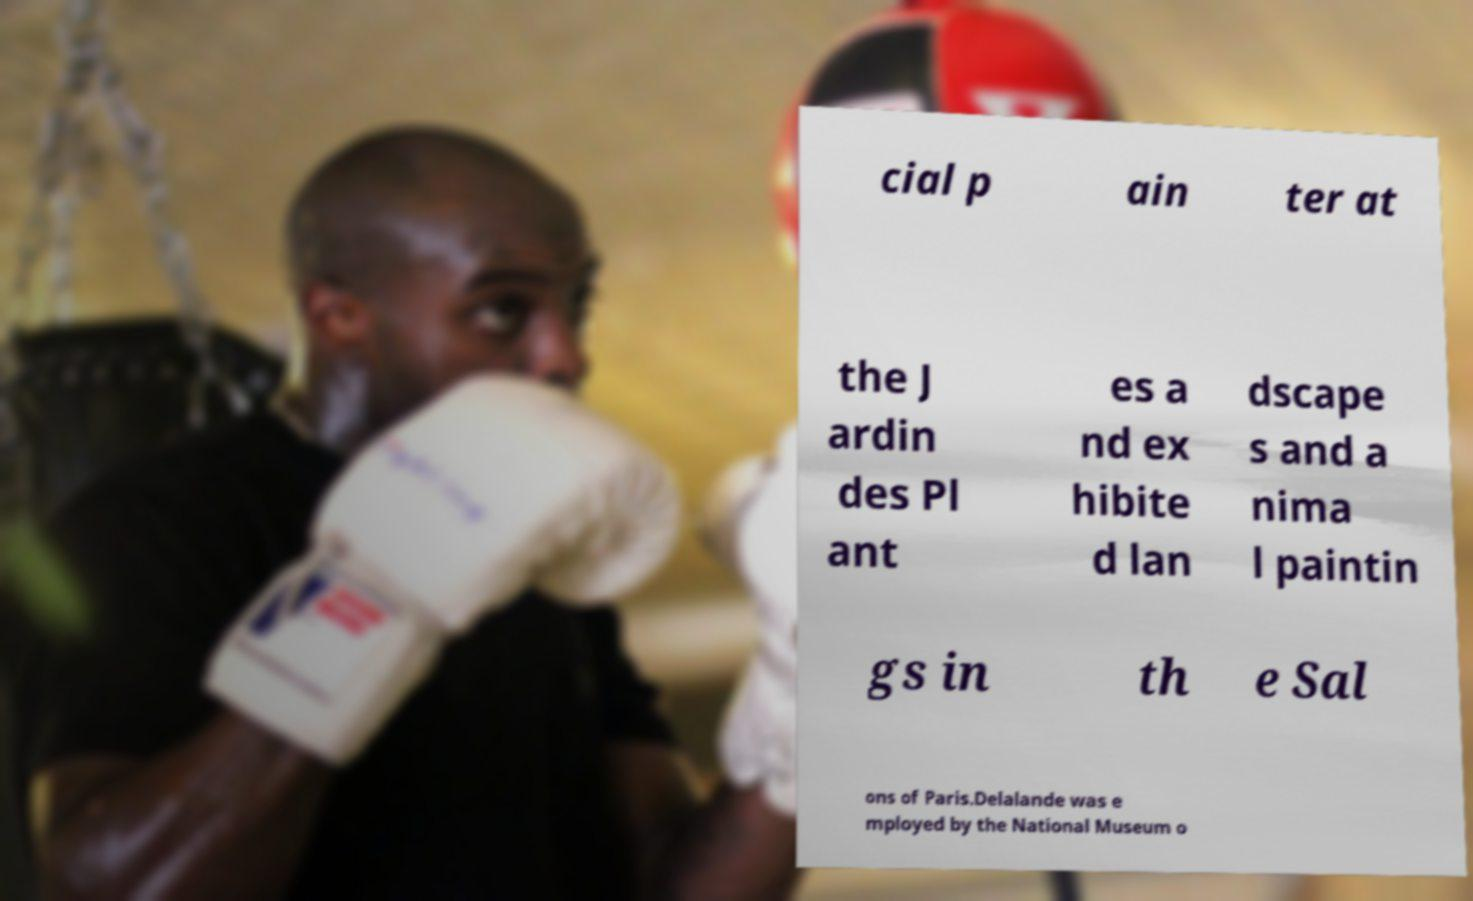Could you assist in decoding the text presented in this image and type it out clearly? cial p ain ter at the J ardin des Pl ant es a nd ex hibite d lan dscape s and a nima l paintin gs in th e Sal ons of Paris.Delalande was e mployed by the National Museum o 